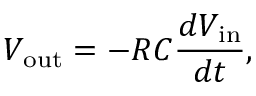<formula> <loc_0><loc_0><loc_500><loc_500>V _ { o u t } = - R C { \frac { d V _ { i n } } { d t } } ,</formula> 